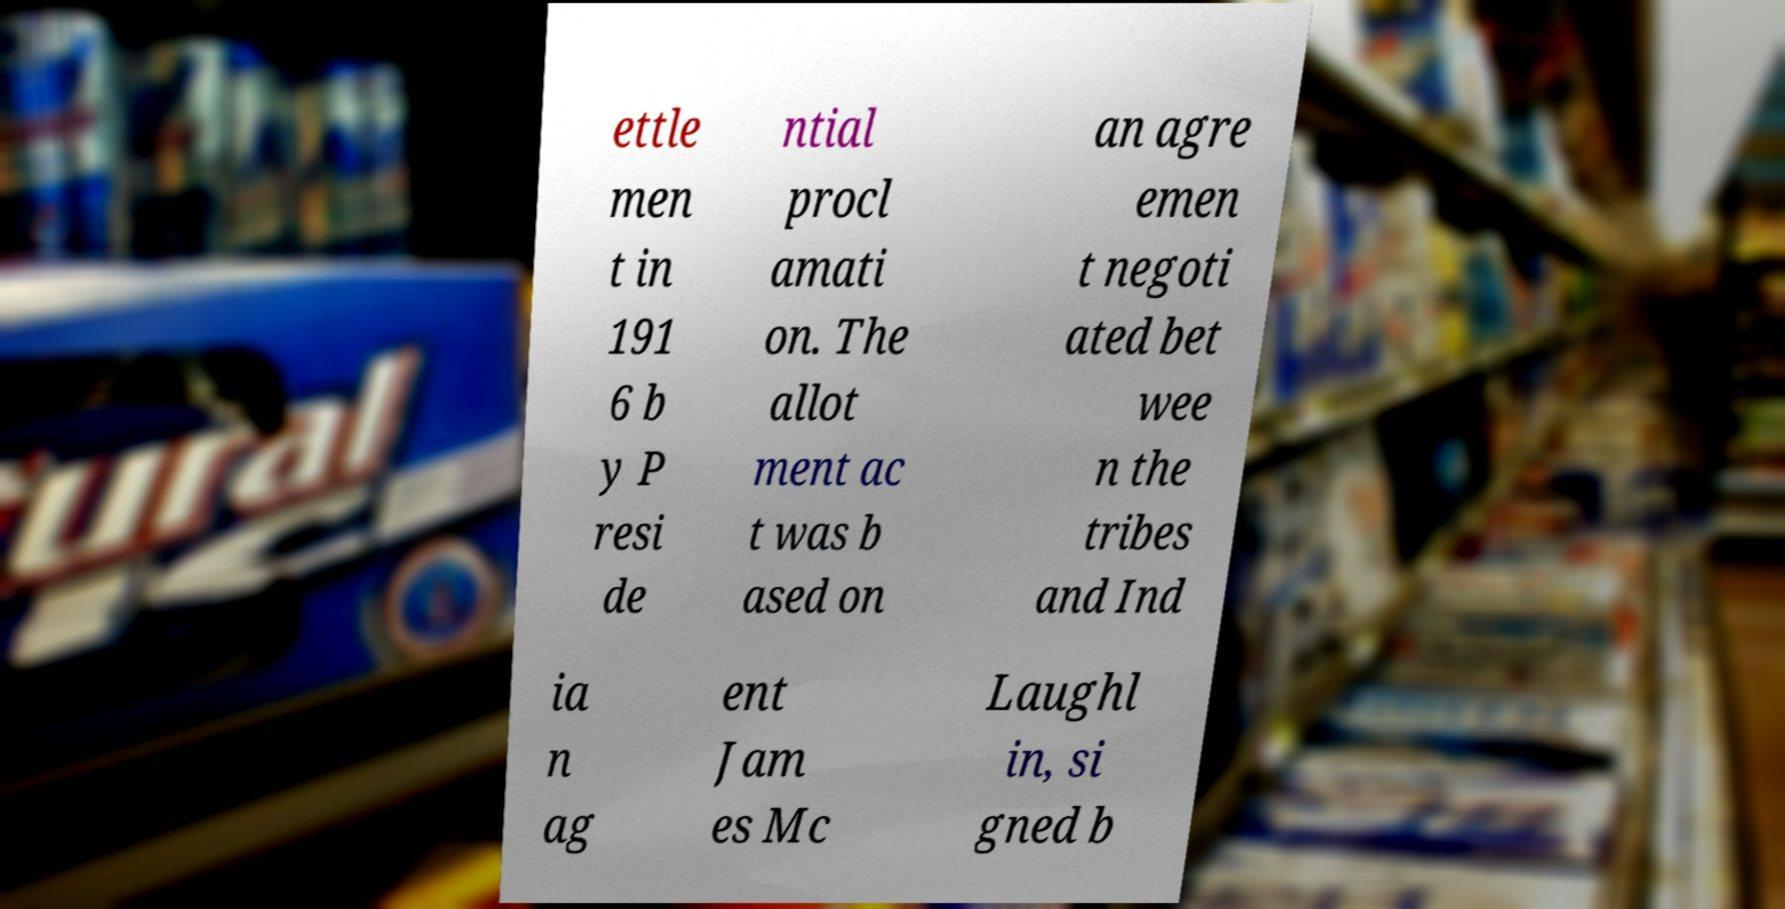Could you assist in decoding the text presented in this image and type it out clearly? ettle men t in 191 6 b y P resi de ntial procl amati on. The allot ment ac t was b ased on an agre emen t negoti ated bet wee n the tribes and Ind ia n ag ent Jam es Mc Laughl in, si gned b 